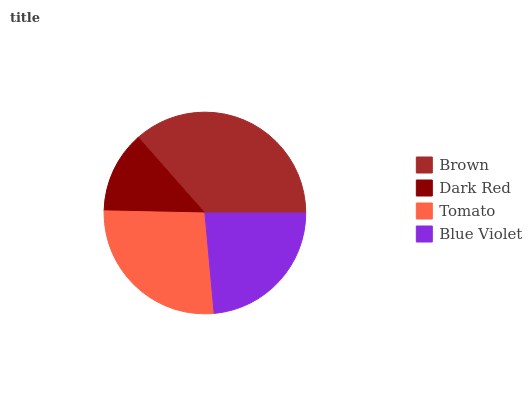Is Dark Red the minimum?
Answer yes or no. Yes. Is Brown the maximum?
Answer yes or no. Yes. Is Tomato the minimum?
Answer yes or no. No. Is Tomato the maximum?
Answer yes or no. No. Is Tomato greater than Dark Red?
Answer yes or no. Yes. Is Dark Red less than Tomato?
Answer yes or no. Yes. Is Dark Red greater than Tomato?
Answer yes or no. No. Is Tomato less than Dark Red?
Answer yes or no. No. Is Tomato the high median?
Answer yes or no. Yes. Is Blue Violet the low median?
Answer yes or no. Yes. Is Dark Red the high median?
Answer yes or no. No. Is Brown the low median?
Answer yes or no. No. 